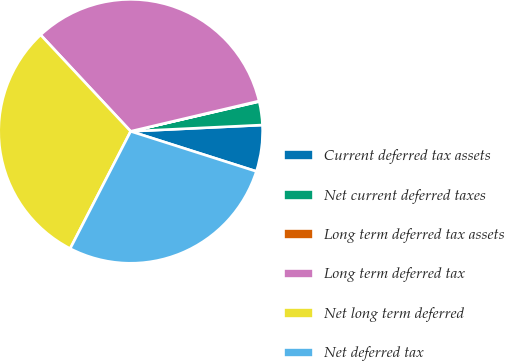Convert chart. <chart><loc_0><loc_0><loc_500><loc_500><pie_chart><fcel>Current deferred tax assets<fcel>Net current deferred taxes<fcel>Long term deferred tax assets<fcel>Long term deferred tax<fcel>Net long term deferred<fcel>Net deferred tax<nl><fcel>5.67%<fcel>2.87%<fcel>0.06%<fcel>33.27%<fcel>30.47%<fcel>27.67%<nl></chart> 